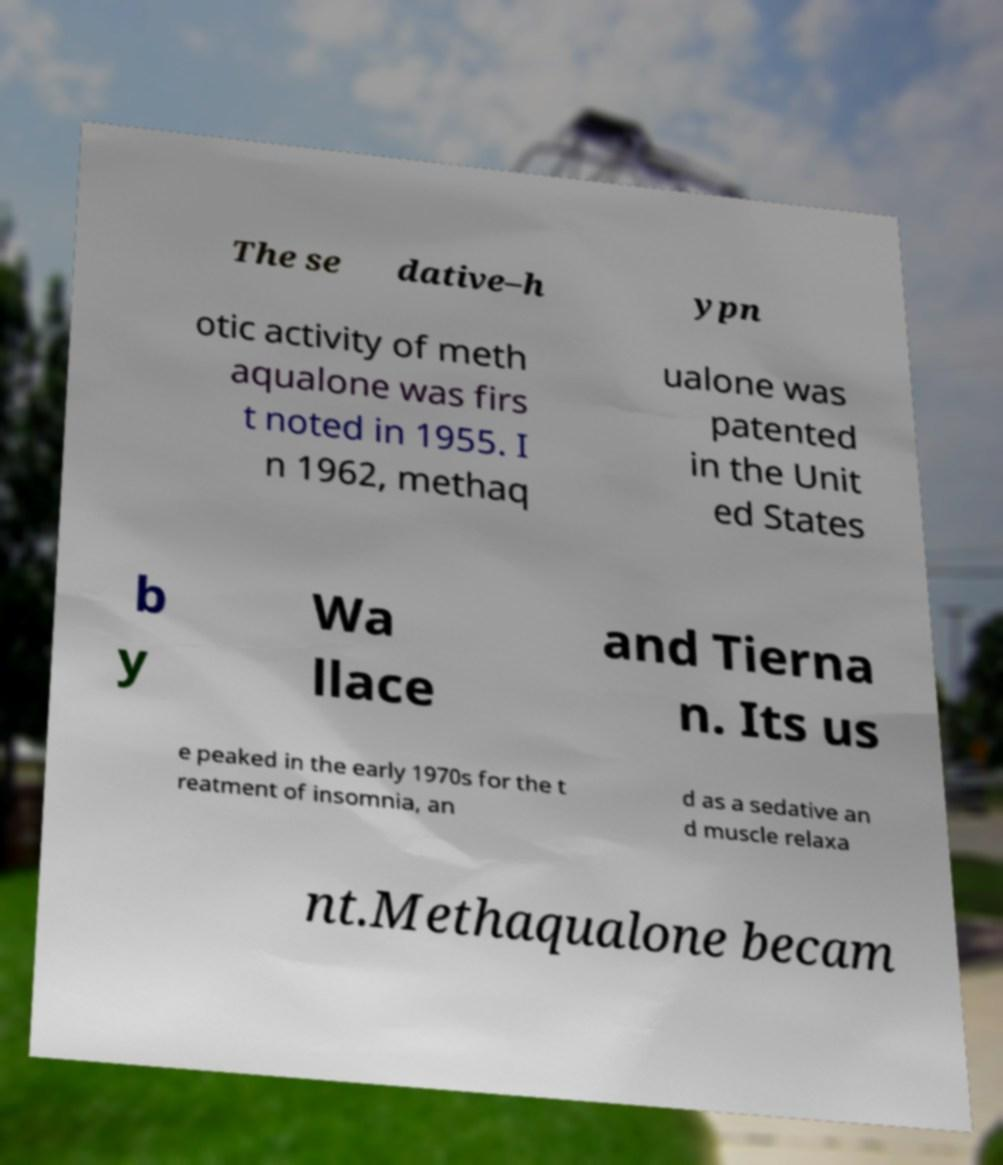There's text embedded in this image that I need extracted. Can you transcribe it verbatim? The se dative–h ypn otic activity of meth aqualone was firs t noted in 1955. I n 1962, methaq ualone was patented in the Unit ed States b y Wa llace and Tierna n. Its us e peaked in the early 1970s for the t reatment of insomnia, an d as a sedative an d muscle relaxa nt.Methaqualone becam 